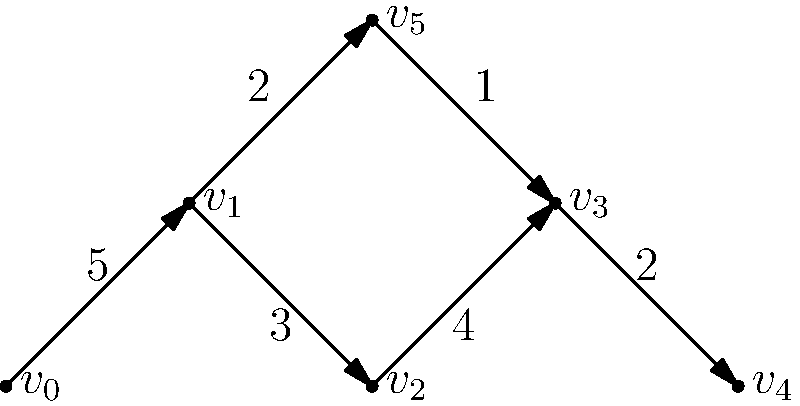In the supply chain network shown above, each vertex represents a stage in the production process, and each edge represents the flow of goods between stages. The weight of each edge indicates the number of reported labor violations at that transition. To expose unethical labor practices, we need to identify the critical path with the highest total number of violations. What is the total number of violations along this critical path? To find the critical path with the highest total number of violations, we need to examine all possible paths from the start ($v_0$) to the end ($v_4$) of the supply chain:

1. Path 1: $v_0 \rightarrow v_1 \rightarrow v_2 \rightarrow v_3 \rightarrow v_4$
   Total violations: $5 + 3 + 4 + 2 = 14$

2. Path 2: $v_0 \rightarrow v_1 \rightarrow v_5 \rightarrow v_3 \rightarrow v_4$
   Total violations: $5 + 2 + 1 + 2 = 10$

The critical path is the one with the highest total number of violations, which is Path 1 with 14 violations.

This path ($v_0 \rightarrow v_1 \rightarrow v_2 \rightarrow v_3 \rightarrow v_4$) represents the sequence of stages in the supply chain where the most labor violations occur, and thus should be the focus of the investigation to expose unethical labor practices.
Answer: 14 